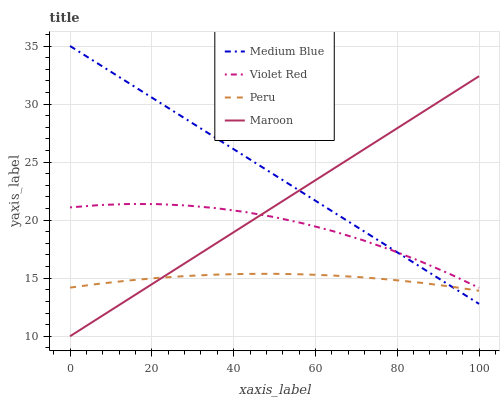Does Peru have the minimum area under the curve?
Answer yes or no. Yes. Does Medium Blue have the maximum area under the curve?
Answer yes or no. Yes. Does Maroon have the minimum area under the curve?
Answer yes or no. No. Does Maroon have the maximum area under the curve?
Answer yes or no. No. Is Maroon the smoothest?
Answer yes or no. Yes. Is Violet Red the roughest?
Answer yes or no. Yes. Is Medium Blue the smoothest?
Answer yes or no. No. Is Medium Blue the roughest?
Answer yes or no. No. Does Maroon have the lowest value?
Answer yes or no. Yes. Does Medium Blue have the lowest value?
Answer yes or no. No. Does Medium Blue have the highest value?
Answer yes or no. Yes. Does Maroon have the highest value?
Answer yes or no. No. Is Peru less than Violet Red?
Answer yes or no. Yes. Is Violet Red greater than Peru?
Answer yes or no. Yes. Does Medium Blue intersect Violet Red?
Answer yes or no. Yes. Is Medium Blue less than Violet Red?
Answer yes or no. No. Is Medium Blue greater than Violet Red?
Answer yes or no. No. Does Peru intersect Violet Red?
Answer yes or no. No. 